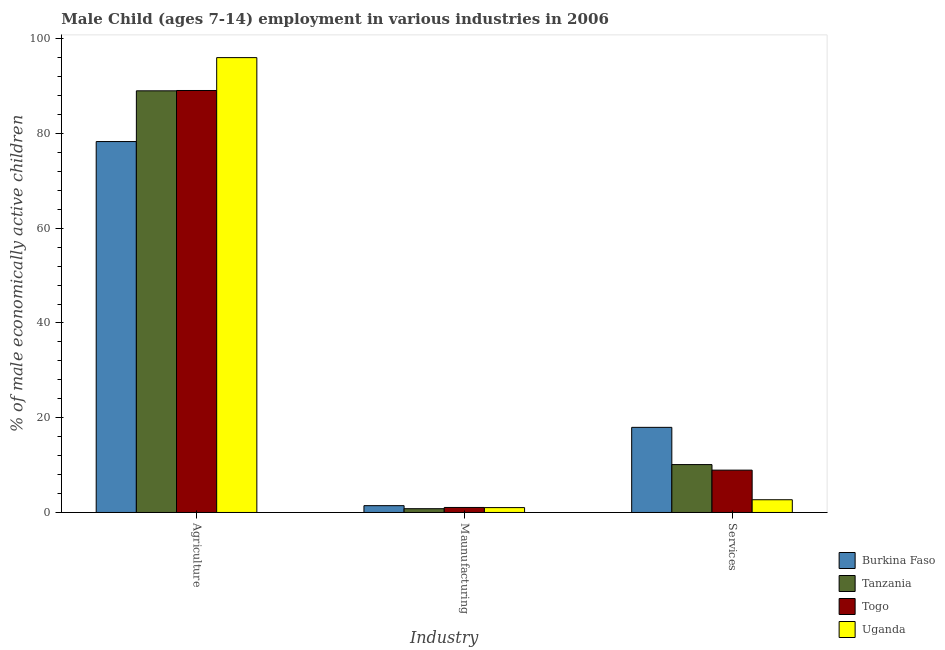How many different coloured bars are there?
Ensure brevity in your answer.  4. Are the number of bars per tick equal to the number of legend labels?
Offer a terse response. Yes. Are the number of bars on each tick of the X-axis equal?
Your answer should be very brief. Yes. How many bars are there on the 3rd tick from the left?
Your response must be concise. 4. How many bars are there on the 1st tick from the right?
Your response must be concise. 4. What is the label of the 2nd group of bars from the left?
Keep it short and to the point. Maunufacturing. What is the percentage of economically active children in services in Burkina Faso?
Your response must be concise. 17.97. Across all countries, what is the maximum percentage of economically active children in manufacturing?
Provide a succinct answer. 1.44. In which country was the percentage of economically active children in agriculture maximum?
Provide a succinct answer. Uganda. In which country was the percentage of economically active children in agriculture minimum?
Provide a succinct answer. Burkina Faso. What is the total percentage of economically active children in agriculture in the graph?
Keep it short and to the point. 352.41. What is the difference between the percentage of economically active children in agriculture in Burkina Faso and that in Uganda?
Offer a terse response. -17.72. What is the difference between the percentage of economically active children in manufacturing in Burkina Faso and the percentage of economically active children in services in Togo?
Your answer should be compact. -7.5. What is the average percentage of economically active children in agriculture per country?
Your answer should be compact. 88.1. What is the difference between the percentage of economically active children in agriculture and percentage of economically active children in manufacturing in Uganda?
Offer a very short reply. 94.99. In how many countries, is the percentage of economically active children in services greater than 84 %?
Ensure brevity in your answer.  0. What is the ratio of the percentage of economically active children in agriculture in Tanzania to that in Burkina Faso?
Your response must be concise. 1.14. What is the difference between the highest and the second highest percentage of economically active children in services?
Your response must be concise. 7.86. What is the difference between the highest and the lowest percentage of economically active children in services?
Give a very brief answer. 15.28. Is the sum of the percentage of economically active children in agriculture in Tanzania and Uganda greater than the maximum percentage of economically active children in manufacturing across all countries?
Your answer should be very brief. Yes. What does the 1st bar from the left in Agriculture represents?
Offer a very short reply. Burkina Faso. What does the 4th bar from the right in Services represents?
Offer a terse response. Burkina Faso. How many countries are there in the graph?
Your answer should be compact. 4. What is the difference between two consecutive major ticks on the Y-axis?
Keep it short and to the point. 20. Are the values on the major ticks of Y-axis written in scientific E-notation?
Ensure brevity in your answer.  No. Does the graph contain grids?
Your response must be concise. No. Where does the legend appear in the graph?
Provide a short and direct response. Bottom right. How are the legend labels stacked?
Offer a terse response. Vertical. What is the title of the graph?
Your answer should be compact. Male Child (ages 7-14) employment in various industries in 2006. Does "St. Martin (French part)" appear as one of the legend labels in the graph?
Keep it short and to the point. No. What is the label or title of the X-axis?
Offer a very short reply. Industry. What is the label or title of the Y-axis?
Your response must be concise. % of male economically active children. What is the % of male economically active children of Burkina Faso in Agriculture?
Offer a terse response. 78.3. What is the % of male economically active children in Tanzania in Agriculture?
Provide a succinct answer. 89.01. What is the % of male economically active children of Togo in Agriculture?
Your answer should be compact. 89.08. What is the % of male economically active children in Uganda in Agriculture?
Ensure brevity in your answer.  96.02. What is the % of male economically active children in Burkina Faso in Maunufacturing?
Provide a succinct answer. 1.44. What is the % of male economically active children of Tanzania in Maunufacturing?
Ensure brevity in your answer.  0.8. What is the % of male economically active children of Togo in Maunufacturing?
Offer a terse response. 1.06. What is the % of male economically active children of Burkina Faso in Services?
Offer a terse response. 17.97. What is the % of male economically active children of Tanzania in Services?
Your response must be concise. 10.11. What is the % of male economically active children in Togo in Services?
Make the answer very short. 8.94. What is the % of male economically active children in Uganda in Services?
Make the answer very short. 2.69. Across all Industry, what is the maximum % of male economically active children in Burkina Faso?
Give a very brief answer. 78.3. Across all Industry, what is the maximum % of male economically active children of Tanzania?
Offer a terse response. 89.01. Across all Industry, what is the maximum % of male economically active children in Togo?
Provide a short and direct response. 89.08. Across all Industry, what is the maximum % of male economically active children in Uganda?
Make the answer very short. 96.02. Across all Industry, what is the minimum % of male economically active children in Burkina Faso?
Provide a short and direct response. 1.44. Across all Industry, what is the minimum % of male economically active children of Togo?
Your answer should be compact. 1.06. Across all Industry, what is the minimum % of male economically active children of Uganda?
Keep it short and to the point. 1.03. What is the total % of male economically active children in Burkina Faso in the graph?
Your response must be concise. 97.71. What is the total % of male economically active children in Tanzania in the graph?
Give a very brief answer. 99.92. What is the total % of male economically active children in Togo in the graph?
Give a very brief answer. 99.08. What is the total % of male economically active children of Uganda in the graph?
Provide a succinct answer. 99.74. What is the difference between the % of male economically active children in Burkina Faso in Agriculture and that in Maunufacturing?
Keep it short and to the point. 76.86. What is the difference between the % of male economically active children in Tanzania in Agriculture and that in Maunufacturing?
Offer a very short reply. 88.21. What is the difference between the % of male economically active children of Togo in Agriculture and that in Maunufacturing?
Your answer should be compact. 88.02. What is the difference between the % of male economically active children in Uganda in Agriculture and that in Maunufacturing?
Offer a terse response. 94.99. What is the difference between the % of male economically active children of Burkina Faso in Agriculture and that in Services?
Make the answer very short. 60.33. What is the difference between the % of male economically active children in Tanzania in Agriculture and that in Services?
Provide a short and direct response. 78.9. What is the difference between the % of male economically active children in Togo in Agriculture and that in Services?
Your answer should be compact. 80.14. What is the difference between the % of male economically active children of Uganda in Agriculture and that in Services?
Provide a succinct answer. 93.33. What is the difference between the % of male economically active children in Burkina Faso in Maunufacturing and that in Services?
Your response must be concise. -16.53. What is the difference between the % of male economically active children of Tanzania in Maunufacturing and that in Services?
Your answer should be compact. -9.31. What is the difference between the % of male economically active children of Togo in Maunufacturing and that in Services?
Make the answer very short. -7.88. What is the difference between the % of male economically active children of Uganda in Maunufacturing and that in Services?
Give a very brief answer. -1.66. What is the difference between the % of male economically active children of Burkina Faso in Agriculture and the % of male economically active children of Tanzania in Maunufacturing?
Provide a succinct answer. 77.5. What is the difference between the % of male economically active children of Burkina Faso in Agriculture and the % of male economically active children of Togo in Maunufacturing?
Give a very brief answer. 77.24. What is the difference between the % of male economically active children of Burkina Faso in Agriculture and the % of male economically active children of Uganda in Maunufacturing?
Offer a terse response. 77.27. What is the difference between the % of male economically active children in Tanzania in Agriculture and the % of male economically active children in Togo in Maunufacturing?
Provide a short and direct response. 87.95. What is the difference between the % of male economically active children in Tanzania in Agriculture and the % of male economically active children in Uganda in Maunufacturing?
Your answer should be very brief. 87.98. What is the difference between the % of male economically active children in Togo in Agriculture and the % of male economically active children in Uganda in Maunufacturing?
Provide a succinct answer. 88.05. What is the difference between the % of male economically active children in Burkina Faso in Agriculture and the % of male economically active children in Tanzania in Services?
Your answer should be compact. 68.19. What is the difference between the % of male economically active children of Burkina Faso in Agriculture and the % of male economically active children of Togo in Services?
Provide a succinct answer. 69.36. What is the difference between the % of male economically active children of Burkina Faso in Agriculture and the % of male economically active children of Uganda in Services?
Your answer should be very brief. 75.61. What is the difference between the % of male economically active children of Tanzania in Agriculture and the % of male economically active children of Togo in Services?
Your answer should be very brief. 80.07. What is the difference between the % of male economically active children of Tanzania in Agriculture and the % of male economically active children of Uganda in Services?
Make the answer very short. 86.32. What is the difference between the % of male economically active children in Togo in Agriculture and the % of male economically active children in Uganda in Services?
Give a very brief answer. 86.39. What is the difference between the % of male economically active children in Burkina Faso in Maunufacturing and the % of male economically active children in Tanzania in Services?
Your answer should be very brief. -8.67. What is the difference between the % of male economically active children in Burkina Faso in Maunufacturing and the % of male economically active children in Uganda in Services?
Your answer should be compact. -1.25. What is the difference between the % of male economically active children of Tanzania in Maunufacturing and the % of male economically active children of Togo in Services?
Your response must be concise. -8.14. What is the difference between the % of male economically active children of Tanzania in Maunufacturing and the % of male economically active children of Uganda in Services?
Keep it short and to the point. -1.89. What is the difference between the % of male economically active children of Togo in Maunufacturing and the % of male economically active children of Uganda in Services?
Your response must be concise. -1.63. What is the average % of male economically active children of Burkina Faso per Industry?
Make the answer very short. 32.57. What is the average % of male economically active children in Tanzania per Industry?
Your answer should be compact. 33.31. What is the average % of male economically active children in Togo per Industry?
Give a very brief answer. 33.03. What is the average % of male economically active children in Uganda per Industry?
Your answer should be very brief. 33.25. What is the difference between the % of male economically active children of Burkina Faso and % of male economically active children of Tanzania in Agriculture?
Offer a terse response. -10.71. What is the difference between the % of male economically active children in Burkina Faso and % of male economically active children in Togo in Agriculture?
Keep it short and to the point. -10.78. What is the difference between the % of male economically active children in Burkina Faso and % of male economically active children in Uganda in Agriculture?
Ensure brevity in your answer.  -17.72. What is the difference between the % of male economically active children in Tanzania and % of male economically active children in Togo in Agriculture?
Your answer should be compact. -0.07. What is the difference between the % of male economically active children in Tanzania and % of male economically active children in Uganda in Agriculture?
Provide a short and direct response. -7.01. What is the difference between the % of male economically active children of Togo and % of male economically active children of Uganda in Agriculture?
Provide a succinct answer. -6.94. What is the difference between the % of male economically active children of Burkina Faso and % of male economically active children of Tanzania in Maunufacturing?
Your answer should be very brief. 0.64. What is the difference between the % of male economically active children of Burkina Faso and % of male economically active children of Togo in Maunufacturing?
Provide a succinct answer. 0.38. What is the difference between the % of male economically active children of Burkina Faso and % of male economically active children of Uganda in Maunufacturing?
Your answer should be compact. 0.41. What is the difference between the % of male economically active children in Tanzania and % of male economically active children in Togo in Maunufacturing?
Ensure brevity in your answer.  -0.26. What is the difference between the % of male economically active children in Tanzania and % of male economically active children in Uganda in Maunufacturing?
Keep it short and to the point. -0.23. What is the difference between the % of male economically active children of Togo and % of male economically active children of Uganda in Maunufacturing?
Give a very brief answer. 0.03. What is the difference between the % of male economically active children of Burkina Faso and % of male economically active children of Tanzania in Services?
Keep it short and to the point. 7.86. What is the difference between the % of male economically active children in Burkina Faso and % of male economically active children in Togo in Services?
Offer a terse response. 9.03. What is the difference between the % of male economically active children of Burkina Faso and % of male economically active children of Uganda in Services?
Keep it short and to the point. 15.28. What is the difference between the % of male economically active children in Tanzania and % of male economically active children in Togo in Services?
Your answer should be compact. 1.17. What is the difference between the % of male economically active children of Tanzania and % of male economically active children of Uganda in Services?
Your answer should be very brief. 7.42. What is the difference between the % of male economically active children in Togo and % of male economically active children in Uganda in Services?
Your response must be concise. 6.25. What is the ratio of the % of male economically active children of Burkina Faso in Agriculture to that in Maunufacturing?
Your response must be concise. 54.38. What is the ratio of the % of male economically active children in Tanzania in Agriculture to that in Maunufacturing?
Ensure brevity in your answer.  111.26. What is the ratio of the % of male economically active children of Togo in Agriculture to that in Maunufacturing?
Provide a succinct answer. 84.04. What is the ratio of the % of male economically active children in Uganda in Agriculture to that in Maunufacturing?
Your answer should be compact. 93.22. What is the ratio of the % of male economically active children in Burkina Faso in Agriculture to that in Services?
Offer a very short reply. 4.36. What is the ratio of the % of male economically active children in Tanzania in Agriculture to that in Services?
Your answer should be very brief. 8.8. What is the ratio of the % of male economically active children in Togo in Agriculture to that in Services?
Provide a succinct answer. 9.96. What is the ratio of the % of male economically active children in Uganda in Agriculture to that in Services?
Ensure brevity in your answer.  35.7. What is the ratio of the % of male economically active children in Burkina Faso in Maunufacturing to that in Services?
Ensure brevity in your answer.  0.08. What is the ratio of the % of male economically active children in Tanzania in Maunufacturing to that in Services?
Offer a terse response. 0.08. What is the ratio of the % of male economically active children in Togo in Maunufacturing to that in Services?
Your answer should be compact. 0.12. What is the ratio of the % of male economically active children of Uganda in Maunufacturing to that in Services?
Ensure brevity in your answer.  0.38. What is the difference between the highest and the second highest % of male economically active children of Burkina Faso?
Your answer should be compact. 60.33. What is the difference between the highest and the second highest % of male economically active children in Tanzania?
Keep it short and to the point. 78.9. What is the difference between the highest and the second highest % of male economically active children of Togo?
Make the answer very short. 80.14. What is the difference between the highest and the second highest % of male economically active children in Uganda?
Your answer should be compact. 93.33. What is the difference between the highest and the lowest % of male economically active children of Burkina Faso?
Give a very brief answer. 76.86. What is the difference between the highest and the lowest % of male economically active children of Tanzania?
Your answer should be very brief. 88.21. What is the difference between the highest and the lowest % of male economically active children in Togo?
Provide a succinct answer. 88.02. What is the difference between the highest and the lowest % of male economically active children of Uganda?
Offer a terse response. 94.99. 